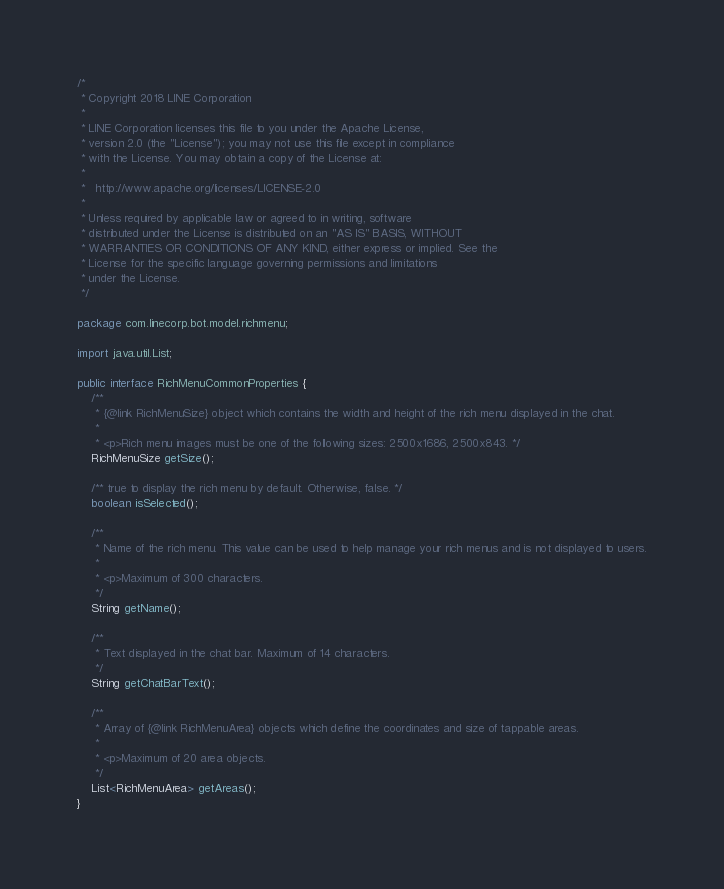<code> <loc_0><loc_0><loc_500><loc_500><_Java_>/*
 * Copyright 2018 LINE Corporation
 *
 * LINE Corporation licenses this file to you under the Apache License,
 * version 2.0 (the "License"); you may not use this file except in compliance
 * with the License. You may obtain a copy of the License at:
 *
 *   http://www.apache.org/licenses/LICENSE-2.0
 *
 * Unless required by applicable law or agreed to in writing, software
 * distributed under the License is distributed on an "AS IS" BASIS, WITHOUT
 * WARRANTIES OR CONDITIONS OF ANY KIND, either express or implied. See the
 * License for the specific language governing permissions and limitations
 * under the License.
 */

package com.linecorp.bot.model.richmenu;

import java.util.List;

public interface RichMenuCommonProperties {
    /**
     * {@link RichMenuSize} object which contains the width and height of the rich menu displayed in the chat.
     *
     * <p>Rich menu images must be one of the following sizes: 2500x1686, 2500x843. */
    RichMenuSize getSize();

    /** true to display the rich menu by default. Otherwise, false. */
    boolean isSelected();

    /**
     * Name of the rich menu. This value can be used to help manage your rich menus and is not displayed to users.
     *
     * <p>Maximum of 300 characters.
     */
    String getName();

    /**
     * Text displayed in the chat bar. Maximum of 14 characters.
     */
    String getChatBarText();

    /**
     * Array of {@link RichMenuArea} objects which define the coordinates and size of tappable areas.
     *
     * <p>Maximum of 20 area objects.
     */
    List<RichMenuArea> getAreas();
}
</code> 